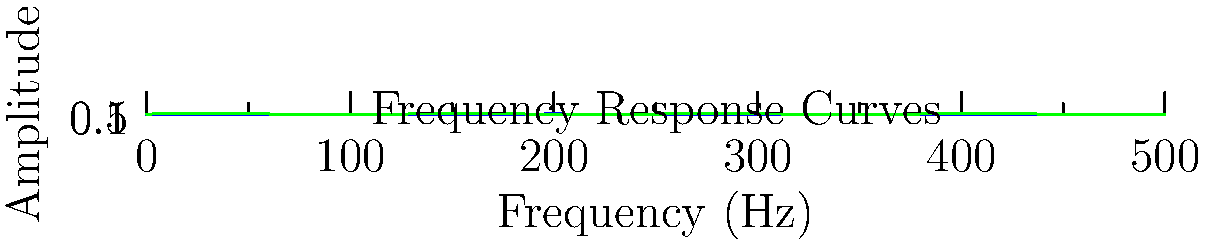Based on the frequency response curves shown in the graph, which instrument would require the most significant boost in the mid-range frequencies (around 250 Hz) to achieve a balanced sound in a live mix? To determine which instrument requires the most significant boost in the mid-range frequencies (around 250 Hz), we need to analyze the frequency response curves for each instrument:

1. Guitar (red curve):
   - Peaks around 50 Hz
   - Gradually decreases in amplitude as frequency increases
   - At 250 Hz, the amplitude is relatively low

2. Bass (blue curve):
   - Peaks around 200 Hz
   - Has a high amplitude at 250 Hz
   - Maintains a relatively high amplitude in the mid-range

3. Drums (green curve):
   - Shows a sinusoidal pattern
   - Has a moderate amplitude at 250 Hz
   - Fluctuates throughout the frequency range

Comparing the three curves at 250 Hz:
- The guitar has the lowest amplitude
- The bass has the highest amplitude
- The drums have a moderate amplitude

To achieve a balanced sound in a live mix, we need to boost the instrument with the lowest amplitude in the mid-range. In this case, the guitar (red curve) has the lowest amplitude at 250 Hz and would require the most significant boost to balance it with the other instruments.
Answer: Guitar 